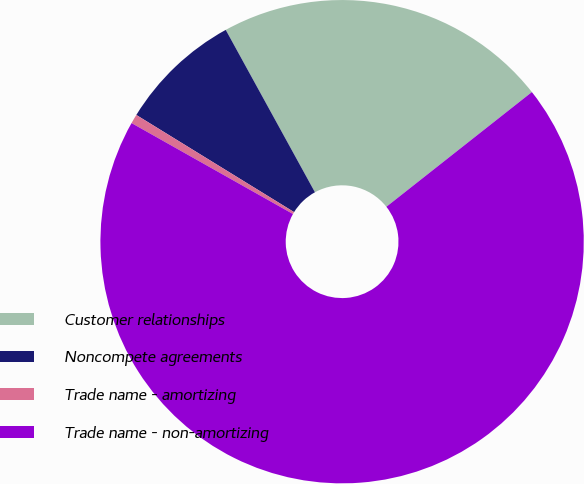Convert chart to OTSL. <chart><loc_0><loc_0><loc_500><loc_500><pie_chart><fcel>Customer relationships<fcel>Noncompete agreements<fcel>Trade name - amortizing<fcel>Trade name - non-amortizing<nl><fcel>22.37%<fcel>8.22%<fcel>0.62%<fcel>68.79%<nl></chart> 